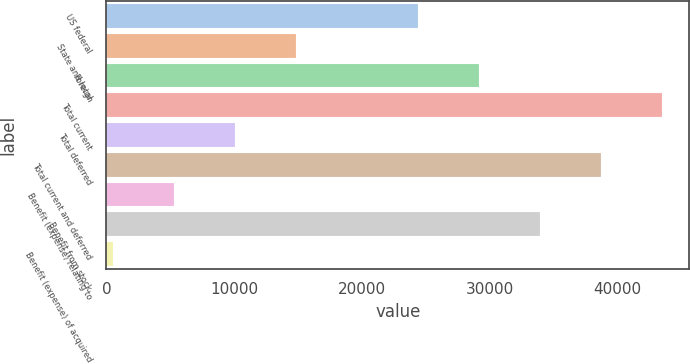Convert chart. <chart><loc_0><loc_0><loc_500><loc_500><bar_chart><fcel>US federal<fcel>State and local<fcel>Foreign<fcel>Total current<fcel>Total deferred<fcel>Total current and deferred<fcel>Benefit (expense) relating to<fcel>Benefit from stock<fcel>Benefit (expense) of acquired<nl><fcel>24364<fcel>14823.6<fcel>29134.2<fcel>43444.8<fcel>10053.4<fcel>38674.6<fcel>5283.2<fcel>33904.4<fcel>513<nl></chart> 